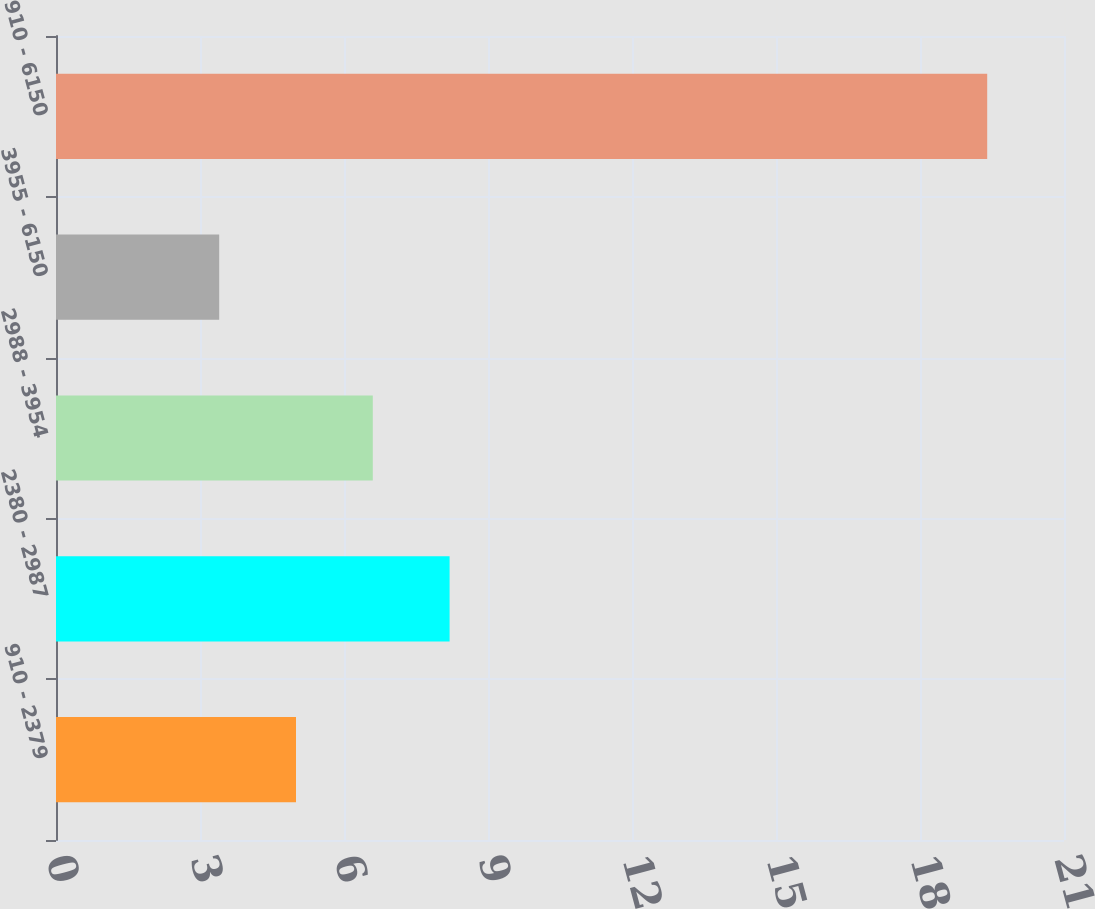<chart> <loc_0><loc_0><loc_500><loc_500><bar_chart><fcel>910 - 2379<fcel>2380 - 2987<fcel>2988 - 3954<fcel>3955 - 6150<fcel>910 - 6150<nl><fcel>5<fcel>8.2<fcel>6.6<fcel>3.4<fcel>19.4<nl></chart> 